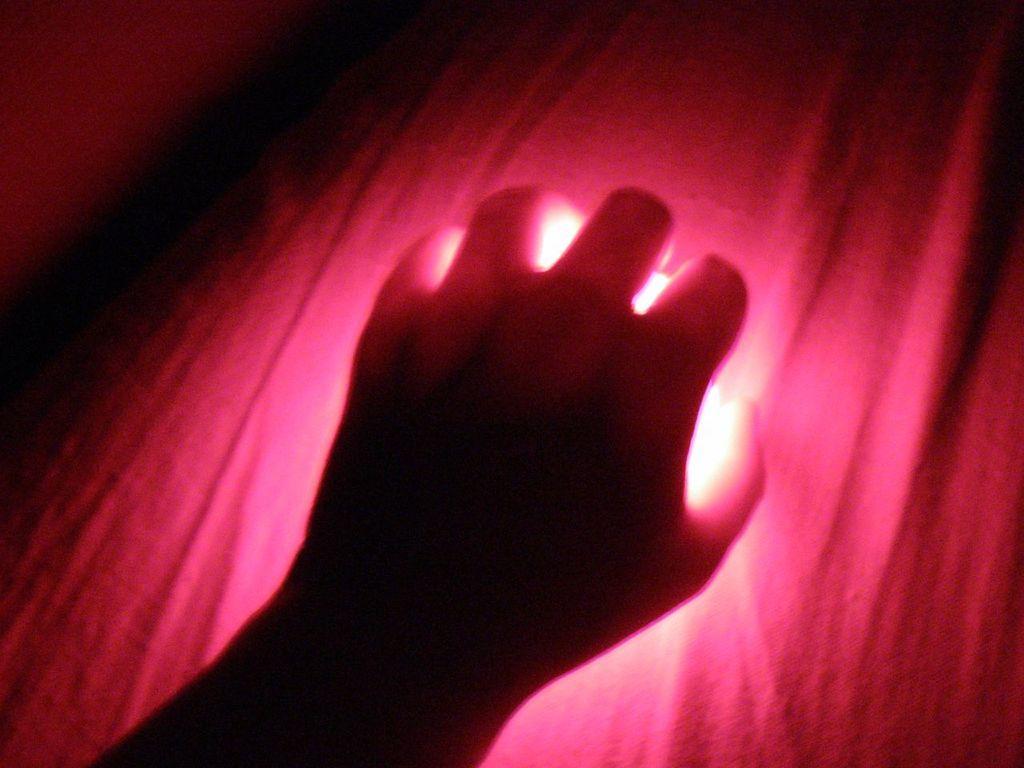Describe this image in one or two sentences. In this image I can see a person hand. Background is in pink color. 